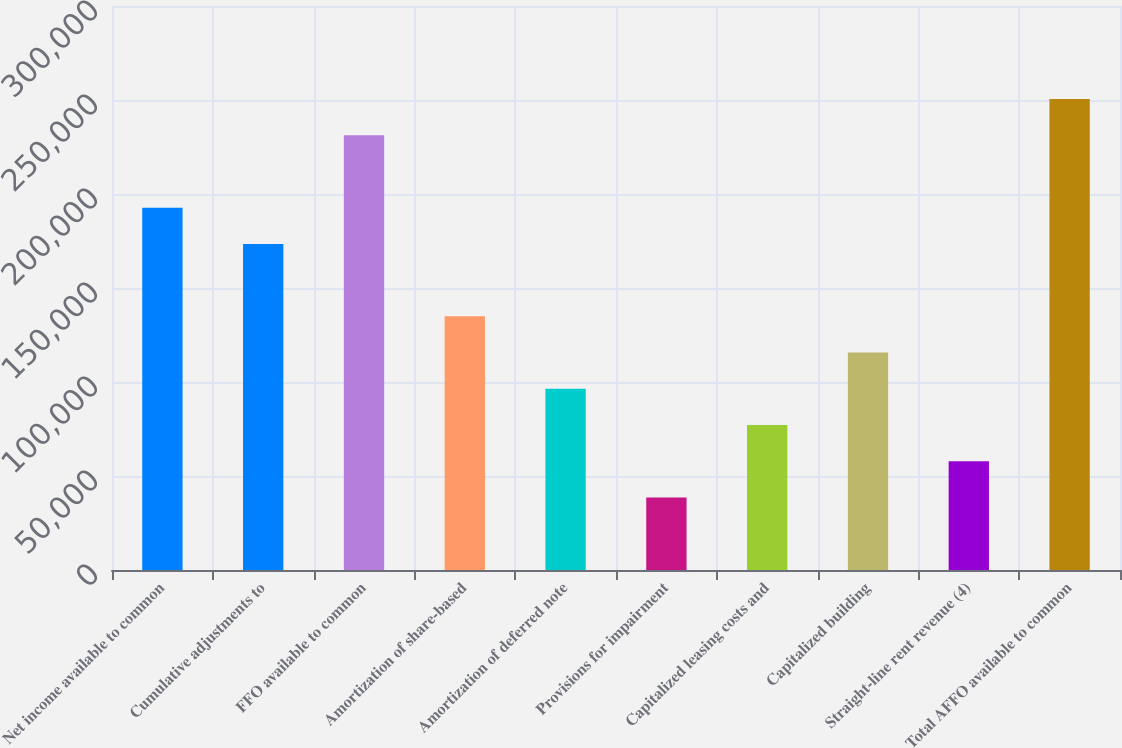Convert chart to OTSL. <chart><loc_0><loc_0><loc_500><loc_500><bar_chart><fcel>Net income available to common<fcel>Cumulative adjustments to<fcel>FFO available to common<fcel>Amortization of share-based<fcel>Amortization of deferred note<fcel>Provisions for impairment<fcel>Capitalized leasing costs and<fcel>Capitalized building<fcel>Straight-line rent revenue (4)<fcel>Total AFFO available to common<nl><fcel>192739<fcel>173465<fcel>231286<fcel>134918<fcel>96370.4<fcel>38549.3<fcel>77096.7<fcel>115644<fcel>57823<fcel>250560<nl></chart> 